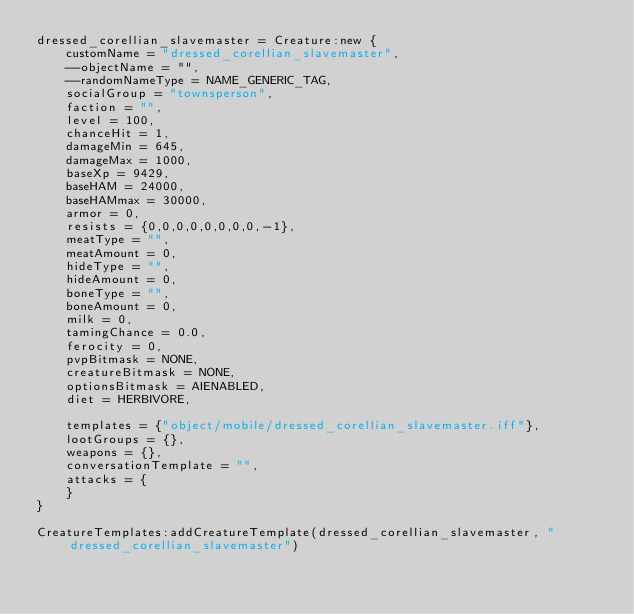Convert code to text. <code><loc_0><loc_0><loc_500><loc_500><_Lua_>dressed_corellian_slavemaster = Creature:new {
	customName = "dressed_corellian_slavemaster",
	--objectName = "",
	--randomNameType = NAME_GENERIC_TAG,
	socialGroup = "townsperson",
	faction = "",
	level = 100,
	chanceHit = 1,
	damageMin = 645,
	damageMax = 1000,
	baseXp = 9429,
	baseHAM = 24000,
	baseHAMmax = 30000,
	armor = 0,
	resists = {0,0,0,0,0,0,0,0,-1},
	meatType = "",
	meatAmount = 0,
	hideType = "",
	hideAmount = 0,
	boneType = "",
	boneAmount = 0,
	milk = 0,
	tamingChance = 0.0,
	ferocity = 0,
	pvpBitmask = NONE,
	creatureBitmask = NONE,
	optionsBitmask = AIENABLED,
	diet = HERBIVORE,

	templates = {"object/mobile/dressed_corellian_slavemaster.iff"},
	lootGroups = {},
	weapons = {},
	conversationTemplate = "",
	attacks = {
	}
}

CreatureTemplates:addCreatureTemplate(dressed_corellian_slavemaster, "dressed_corellian_slavemaster")

</code> 